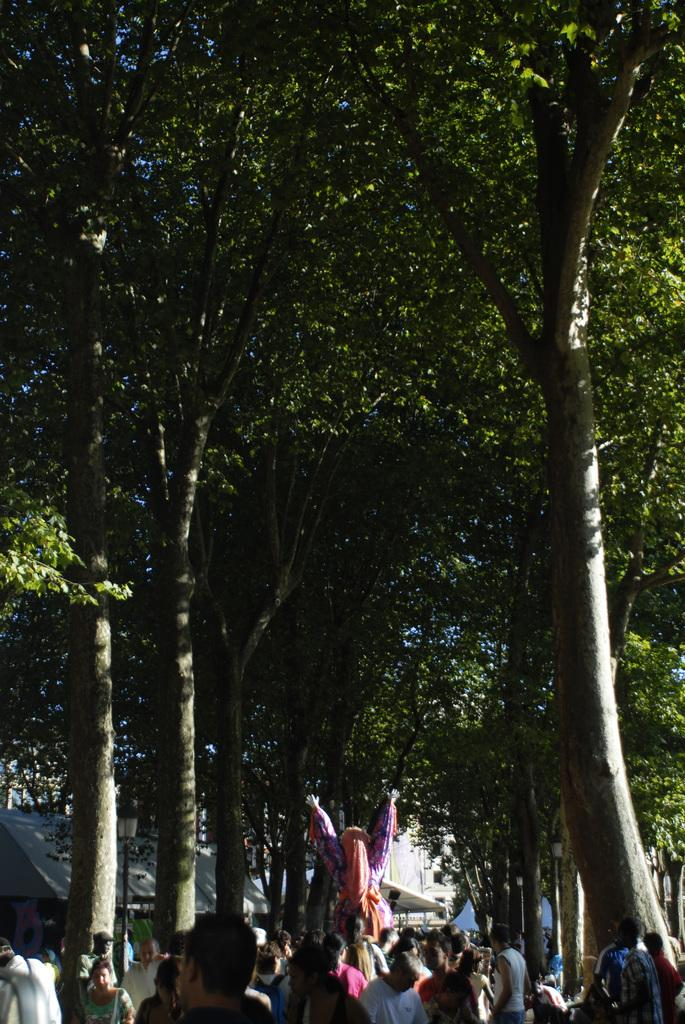What type of natural vegetation is present in the image? There is a group of trees in the image. What else can be seen in the image besides the trees? There is a group of people and a building in the image. What is the relationship between the two people in the image? One person is holding another person in the image. Can you see a hen swimming in the water in the image? There is no hen or water present in the image. 